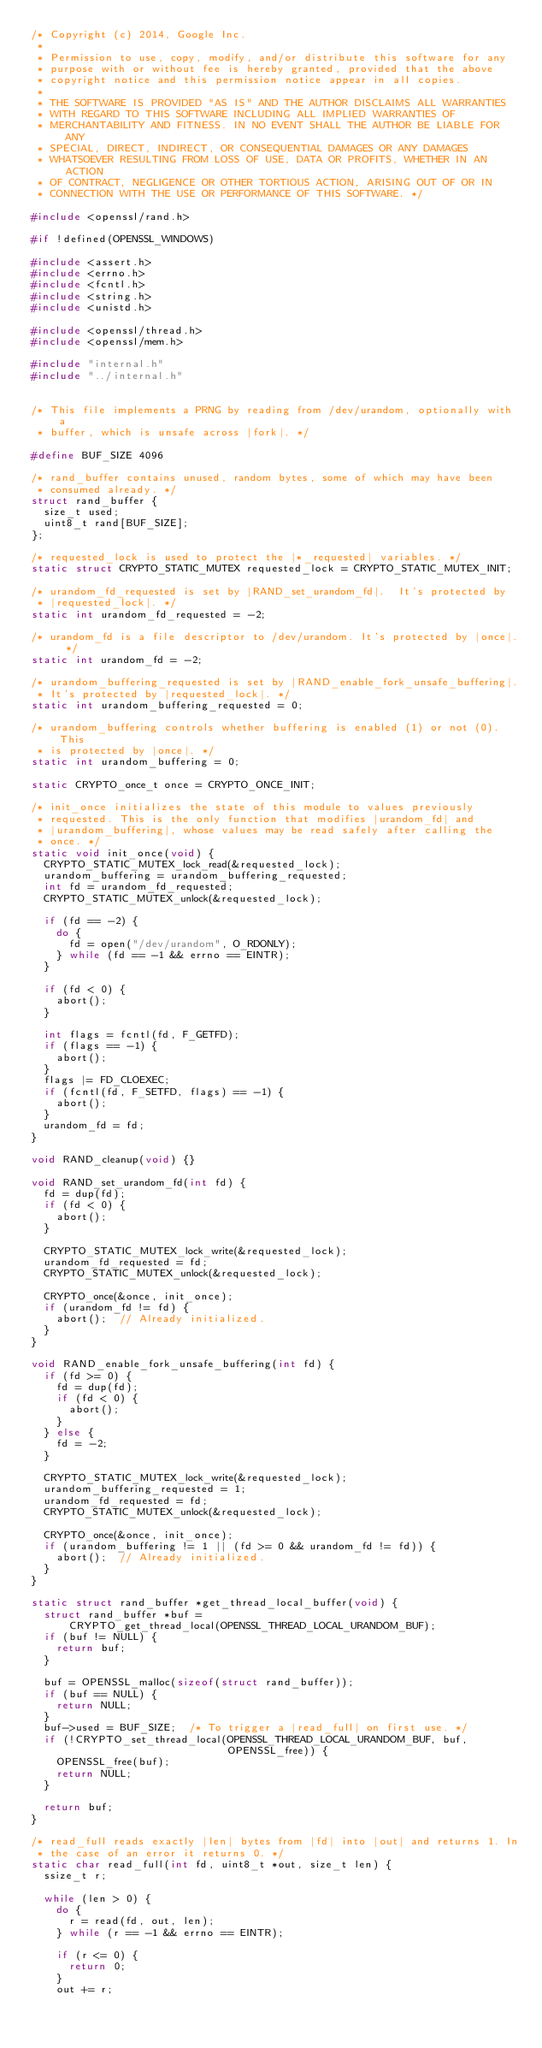Convert code to text. <code><loc_0><loc_0><loc_500><loc_500><_C_>/* Copyright (c) 2014, Google Inc.
 *
 * Permission to use, copy, modify, and/or distribute this software for any
 * purpose with or without fee is hereby granted, provided that the above
 * copyright notice and this permission notice appear in all copies.
 *
 * THE SOFTWARE IS PROVIDED "AS IS" AND THE AUTHOR DISCLAIMS ALL WARRANTIES
 * WITH REGARD TO THIS SOFTWARE INCLUDING ALL IMPLIED WARRANTIES OF
 * MERCHANTABILITY AND FITNESS. IN NO EVENT SHALL THE AUTHOR BE LIABLE FOR ANY
 * SPECIAL, DIRECT, INDIRECT, OR CONSEQUENTIAL DAMAGES OR ANY DAMAGES
 * WHATSOEVER RESULTING FROM LOSS OF USE, DATA OR PROFITS, WHETHER IN AN ACTION
 * OF CONTRACT, NEGLIGENCE OR OTHER TORTIOUS ACTION, ARISING OUT OF OR IN
 * CONNECTION WITH THE USE OR PERFORMANCE OF THIS SOFTWARE. */

#include <openssl/rand.h>

#if !defined(OPENSSL_WINDOWS)

#include <assert.h>
#include <errno.h>
#include <fcntl.h>
#include <string.h>
#include <unistd.h>

#include <openssl/thread.h>
#include <openssl/mem.h>

#include "internal.h"
#include "../internal.h"


/* This file implements a PRNG by reading from /dev/urandom, optionally with a
 * buffer, which is unsafe across |fork|. */

#define BUF_SIZE 4096

/* rand_buffer contains unused, random bytes, some of which may have been
 * consumed already. */
struct rand_buffer {
  size_t used;
  uint8_t rand[BUF_SIZE];
};

/* requested_lock is used to protect the |*_requested| variables. */
static struct CRYPTO_STATIC_MUTEX requested_lock = CRYPTO_STATIC_MUTEX_INIT;

/* urandom_fd_requested is set by |RAND_set_urandom_fd|.  It's protected by
 * |requested_lock|. */
static int urandom_fd_requested = -2;

/* urandom_fd is a file descriptor to /dev/urandom. It's protected by |once|. */
static int urandom_fd = -2;

/* urandom_buffering_requested is set by |RAND_enable_fork_unsafe_buffering|.
 * It's protected by |requested_lock|. */
static int urandom_buffering_requested = 0;

/* urandom_buffering controls whether buffering is enabled (1) or not (0). This
 * is protected by |once|. */
static int urandom_buffering = 0;

static CRYPTO_once_t once = CRYPTO_ONCE_INIT;

/* init_once initializes the state of this module to values previously
 * requested. This is the only function that modifies |urandom_fd| and
 * |urandom_buffering|, whose values may be read safely after calling the
 * once. */
static void init_once(void) {
  CRYPTO_STATIC_MUTEX_lock_read(&requested_lock);
  urandom_buffering = urandom_buffering_requested;
  int fd = urandom_fd_requested;
  CRYPTO_STATIC_MUTEX_unlock(&requested_lock);

  if (fd == -2) {
    do {
      fd = open("/dev/urandom", O_RDONLY);
    } while (fd == -1 && errno == EINTR);
  }

  if (fd < 0) {
    abort();
  }

  int flags = fcntl(fd, F_GETFD);
  if (flags == -1) {
    abort();
  }
  flags |= FD_CLOEXEC;
  if (fcntl(fd, F_SETFD, flags) == -1) {
    abort();
  }
  urandom_fd = fd;
}

void RAND_cleanup(void) {}

void RAND_set_urandom_fd(int fd) {
  fd = dup(fd);
  if (fd < 0) {
    abort();
  }

  CRYPTO_STATIC_MUTEX_lock_write(&requested_lock);
  urandom_fd_requested = fd;
  CRYPTO_STATIC_MUTEX_unlock(&requested_lock);

  CRYPTO_once(&once, init_once);
  if (urandom_fd != fd) {
    abort();  // Already initialized.
  }
}

void RAND_enable_fork_unsafe_buffering(int fd) {
  if (fd >= 0) {
    fd = dup(fd);
    if (fd < 0) {
      abort();
    }
  } else {
    fd = -2;
  }

  CRYPTO_STATIC_MUTEX_lock_write(&requested_lock);
  urandom_buffering_requested = 1;
  urandom_fd_requested = fd;
  CRYPTO_STATIC_MUTEX_unlock(&requested_lock);

  CRYPTO_once(&once, init_once);
  if (urandom_buffering != 1 || (fd >= 0 && urandom_fd != fd)) {
    abort();  // Already initialized.
  }
}

static struct rand_buffer *get_thread_local_buffer(void) {
  struct rand_buffer *buf =
      CRYPTO_get_thread_local(OPENSSL_THREAD_LOCAL_URANDOM_BUF);
  if (buf != NULL) {
    return buf;
  }

  buf = OPENSSL_malloc(sizeof(struct rand_buffer));
  if (buf == NULL) {
    return NULL;
  }
  buf->used = BUF_SIZE;  /* To trigger a |read_full| on first use. */
  if (!CRYPTO_set_thread_local(OPENSSL_THREAD_LOCAL_URANDOM_BUF, buf,
                               OPENSSL_free)) {
    OPENSSL_free(buf);
    return NULL;
  }

  return buf;
}

/* read_full reads exactly |len| bytes from |fd| into |out| and returns 1. In
 * the case of an error it returns 0. */
static char read_full(int fd, uint8_t *out, size_t len) {
  ssize_t r;

  while (len > 0) {
    do {
      r = read(fd, out, len);
    } while (r == -1 && errno == EINTR);

    if (r <= 0) {
      return 0;
    }
    out += r;</code> 